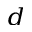<formula> <loc_0><loc_0><loc_500><loc_500>^ { d }</formula> 